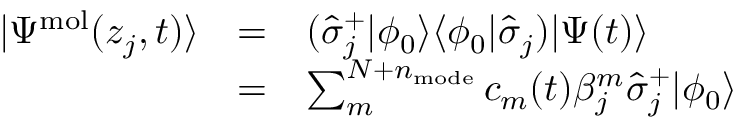<formula> <loc_0><loc_0><loc_500><loc_500>\begin{array} { c c l } { | \Psi ^ { m o l } ( z _ { j } , t ) \rangle } & { = } & { ( \hat { \sigma } _ { j } ^ { + } | \phi _ { 0 } \rangle \langle \phi _ { 0 } | \hat { \sigma } _ { j } ) | \Psi ( t ) \rangle } \\ & { = } & { \sum _ { m } ^ { N + n _ { m o d e } } c _ { m } ( t ) \beta _ { j } ^ { m } \hat { \sigma } _ { j } ^ { + } | \phi _ { 0 } \rangle } \end{array}</formula> 